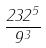Convert formula to latex. <formula><loc_0><loc_0><loc_500><loc_500>\frac { 2 3 2 ^ { 5 } } { 9 ^ { 3 } }</formula> 